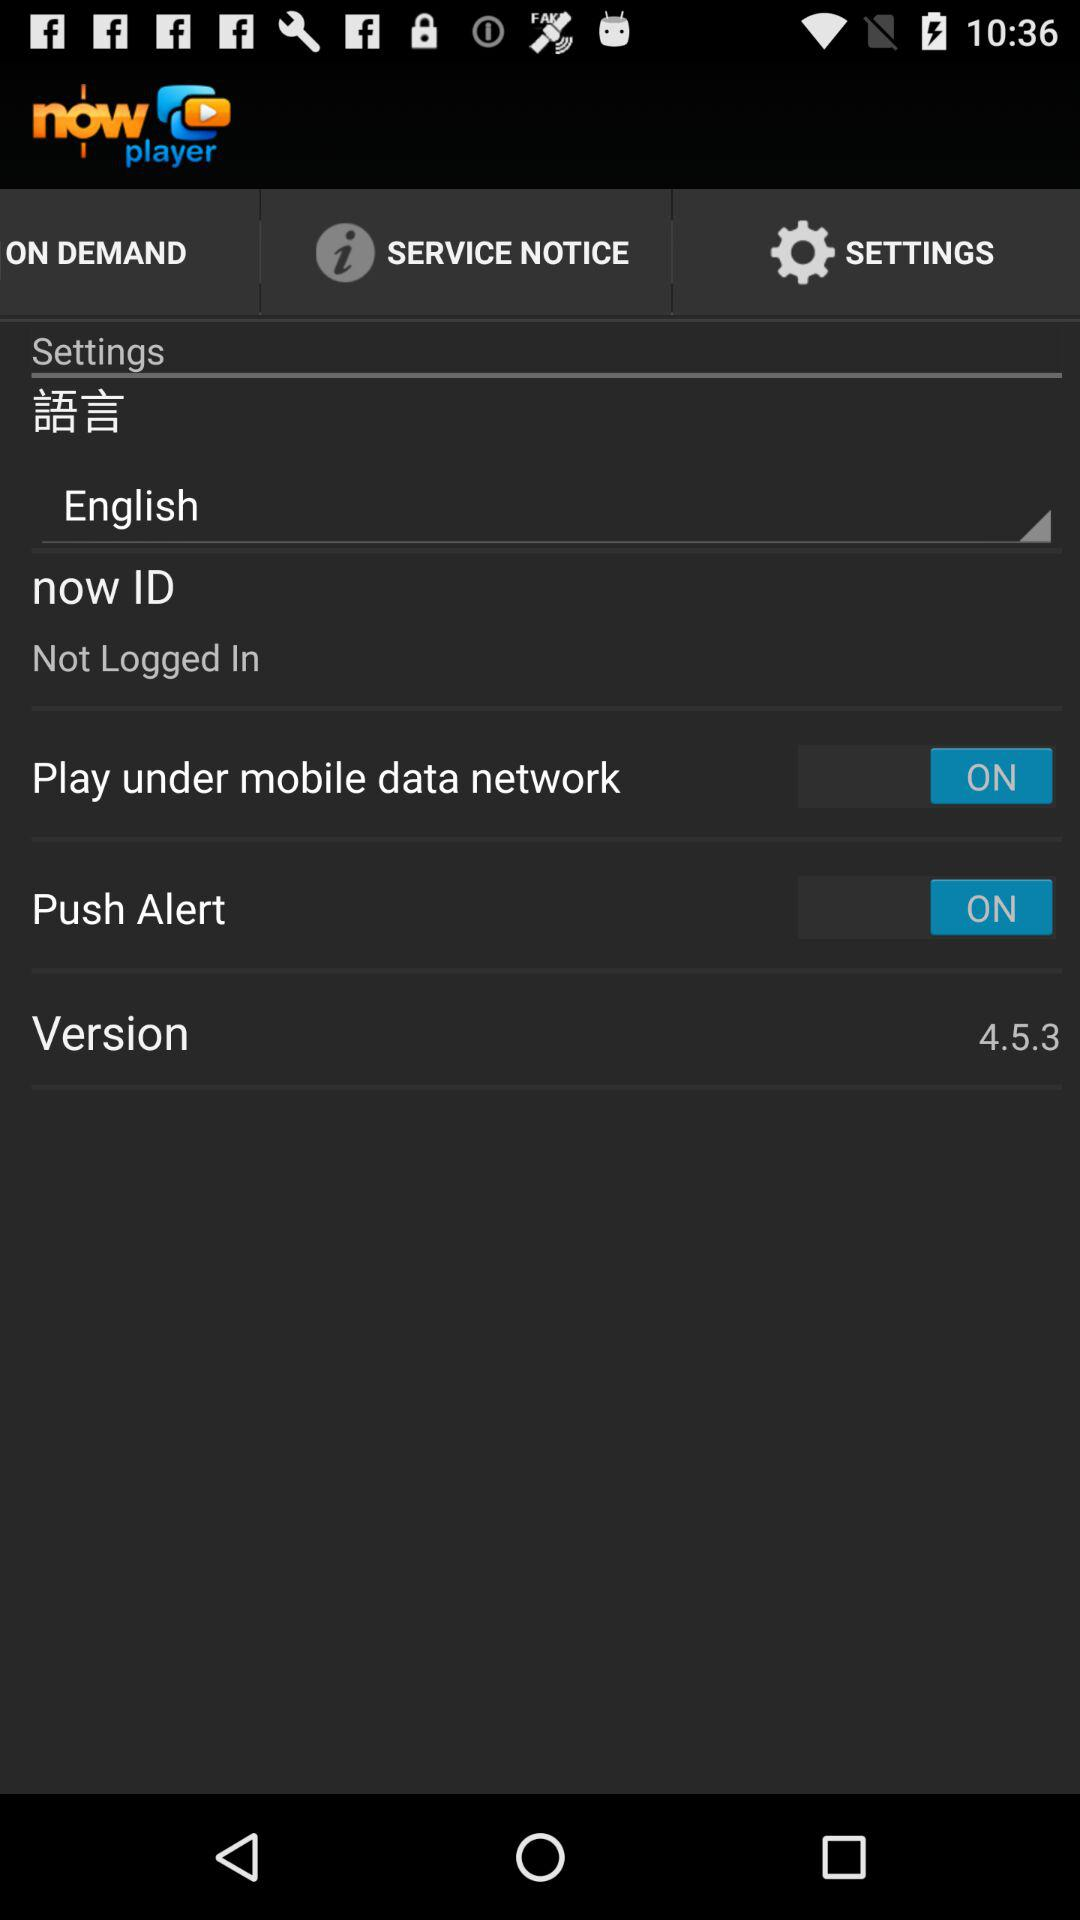How many items in the settings menu have a switch?
Answer the question using a single word or phrase. 2 